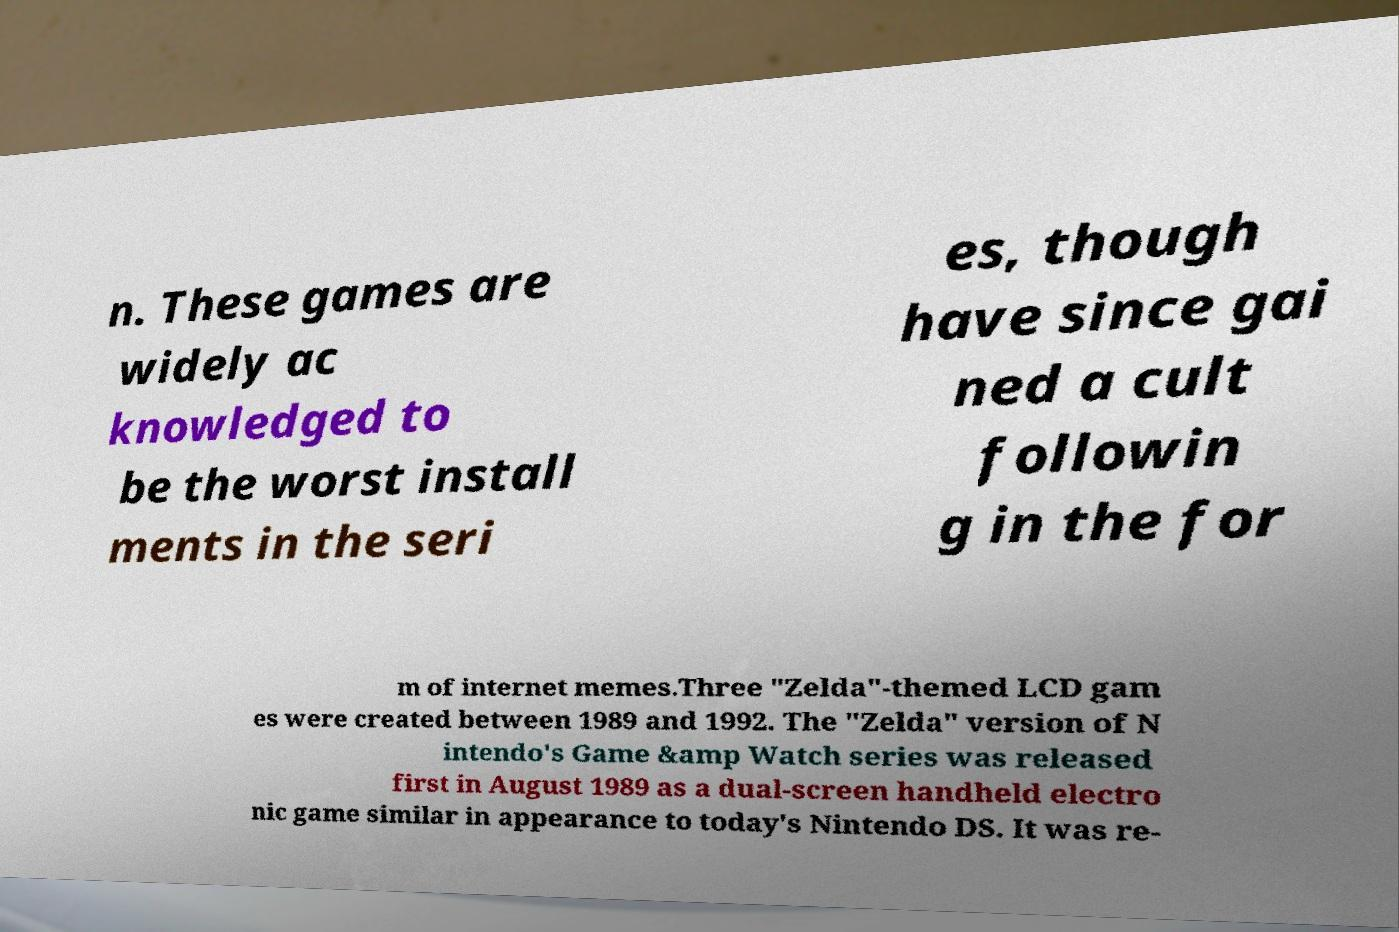Can you read and provide the text displayed in the image?This photo seems to have some interesting text. Can you extract and type it out for me? n. These games are widely ac knowledged to be the worst install ments in the seri es, though have since gai ned a cult followin g in the for m of internet memes.Three "Zelda"-themed LCD gam es were created between 1989 and 1992. The "Zelda" version of N intendo's Game &amp Watch series was released first in August 1989 as a dual-screen handheld electro nic game similar in appearance to today's Nintendo DS. It was re- 